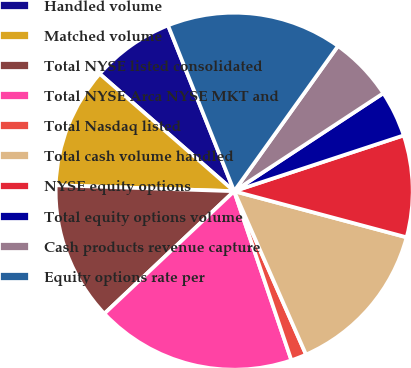<chart> <loc_0><loc_0><loc_500><loc_500><pie_chart><fcel>Handled volume<fcel>Matched volume<fcel>Total NYSE listed consolidated<fcel>Total NYSE Arca NYSE MKT and<fcel>Total Nasdaq listed<fcel>Total cash volume handled<fcel>NYSE equity options<fcel>Total equity options volume<fcel>Cash products revenue capture<fcel>Equity options rate per<nl><fcel>7.54%<fcel>10.89%<fcel>12.57%<fcel>18.16%<fcel>1.4%<fcel>14.25%<fcel>9.22%<fcel>4.19%<fcel>5.87%<fcel>15.92%<nl></chart> 